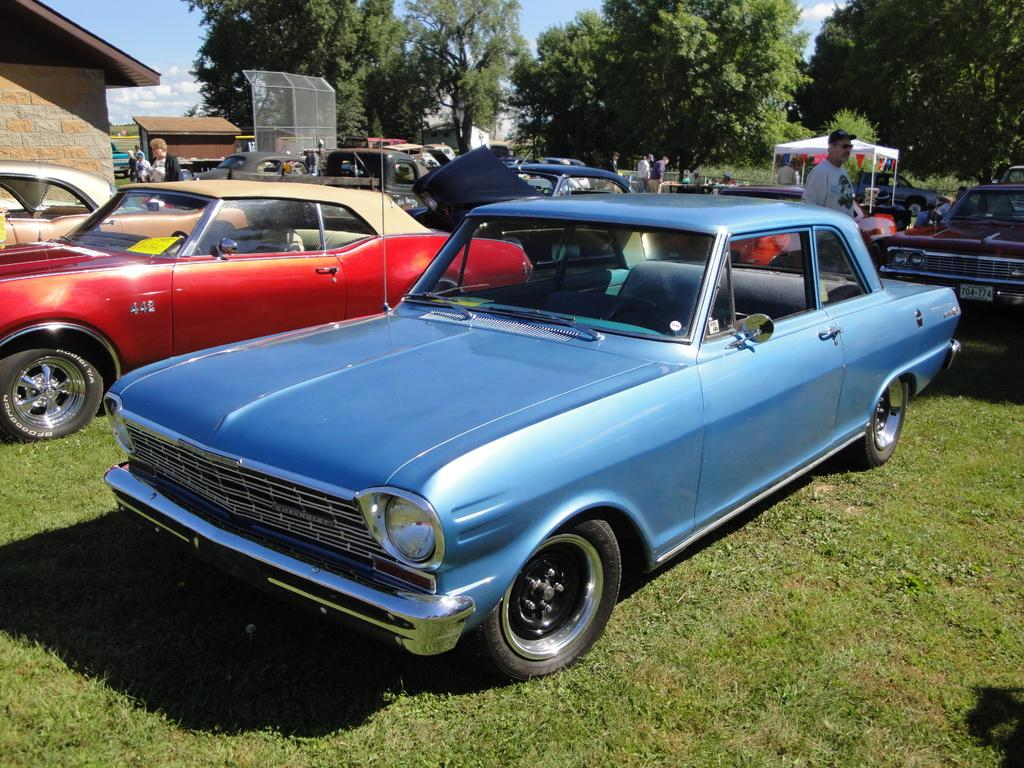What type of vehicles can be seen in the image? There are cars in the image. What are the people in the image doing? The people are on the grass in the image. What type of shelter is visible in the image? There is a tent in the image. What type of vegetation is present in the image? There are trees in the image. What type of structures can be seen in the image? There are houses in the image. What is visible in the background of the image? The sky is visible in the background of the image. What can be seen in the sky? Clouds are present in the sky. What is the weight of the branch hanging from the tree in the image? There is no branch hanging from a tree in the image. How many rocks can be seen on the grass in the image? There are no rocks visible on the grass in the image. 